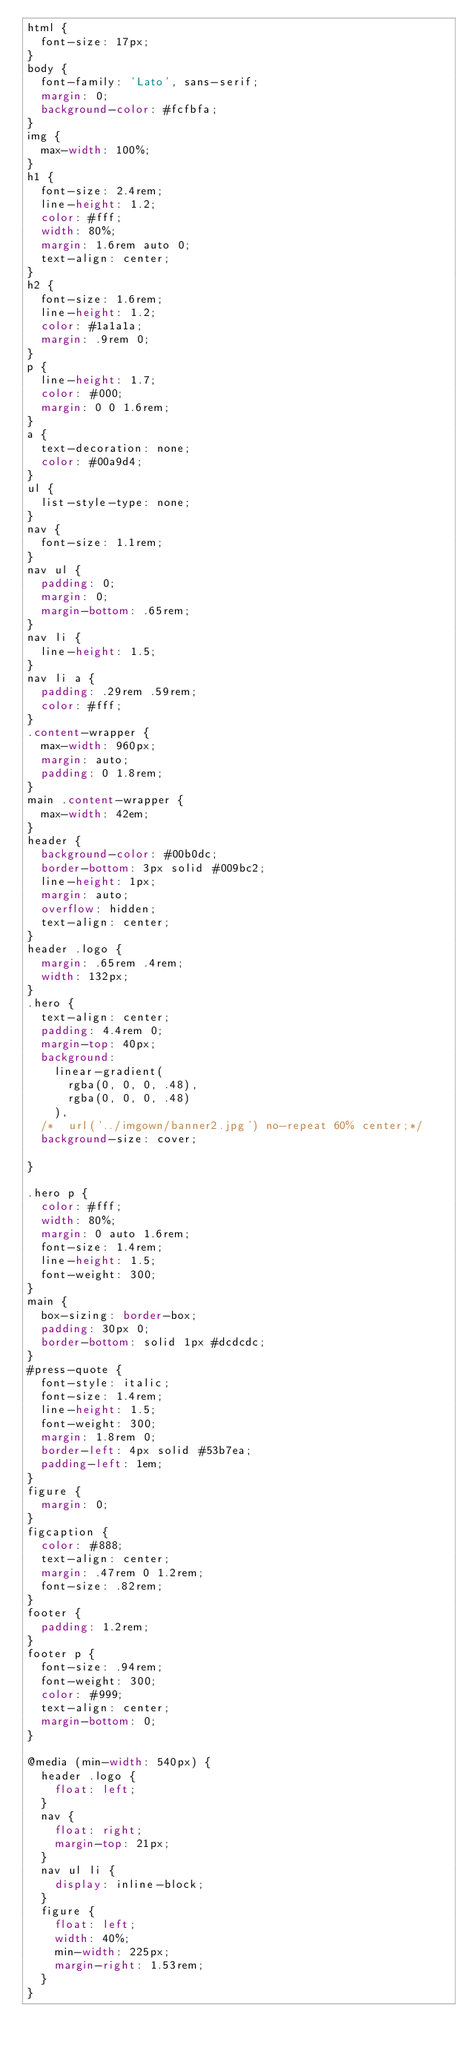Convert code to text. <code><loc_0><loc_0><loc_500><loc_500><_CSS_>html {
	font-size: 17px;
}
body {
	font-family: 'Lato', sans-serif;
	margin: 0;
	background-color: #fcfbfa;
}
img {
	max-width: 100%;
}
h1 {
	font-size: 2.4rem;
	line-height: 1.2;
	color: #fff;
	width: 80%;
	margin: 1.6rem auto 0;
	text-align: center;
}
h2 {
	font-size: 1.6rem;
	line-height: 1.2;
	color: #1a1a1a;
	margin: .9rem 0;
}
p {
	line-height: 1.7;
	color: #000;
	margin: 0 0 1.6rem;
}
a {
	text-decoration: none;
	color: #00a9d4;
}
ul {
	list-style-type: none;
}
nav {
	font-size: 1.1rem;
}
nav ul {
	padding: 0;
	margin: 0;
	margin-bottom: .65rem;
}
nav li {
	line-height: 1.5;
}
nav li a {
	padding: .29rem .59rem;
	color: #fff;
}
.content-wrapper {
	max-width: 960px;
	margin: auto;
	padding: 0 1.8rem;
}
main .content-wrapper {
	max-width: 42em;
}
header {
	background-color: #00b0dc;
	border-bottom: 3px solid #009bc2;
	line-height: 1px;
	margin: auto;
	overflow: hidden;
	text-align: center;
}
header .logo {
	margin: .65rem .4rem;
	width: 132px;
}
.hero {
	text-align: center;
	padding: 4.4rem 0;
	margin-top: 40px;
	background:
		linear-gradient(
			rgba(0, 0, 0, .48),
			rgba(0, 0, 0, .48)
		),
	/*	url('../imgown/banner2.jpg') no-repeat 60% center;*/
	background-size: cover;

}

.hero p {
	color: #fff;
	width: 80%;
	margin: 0 auto 1.6rem;
	font-size: 1.4rem;
	line-height: 1.5;
	font-weight: 300;
}
main {
	box-sizing: border-box;
	padding: 30px 0;
	border-bottom: solid 1px #dcdcdc;
}
#press-quote {
	font-style: italic;
	font-size: 1.4rem;
	line-height: 1.5;
	font-weight: 300;
	margin: 1.8rem 0;
	border-left: 4px solid #53b7ea;
	padding-left: 1em;
}
figure {
	margin: 0;
}
figcaption {
	color: #888;
	text-align: center;
	margin: .47rem 0 1.2rem;
	font-size: .82rem;
}
footer {
	padding: 1.2rem;
}
footer p {
	font-size: .94rem;
	font-weight: 300;
	color: #999;
	text-align: center;
	margin-bottom: 0;
}

@media (min-width: 540px) {
	header .logo {
		float: left;
	}
	nav {
		float: right;
		margin-top: 21px;
	}
	nav ul li {
		display: inline-block;
	}
	figure {
		float: left;
		width: 40%;
		min-width: 225px;
		margin-right: 1.53rem;
	}
}
</code> 